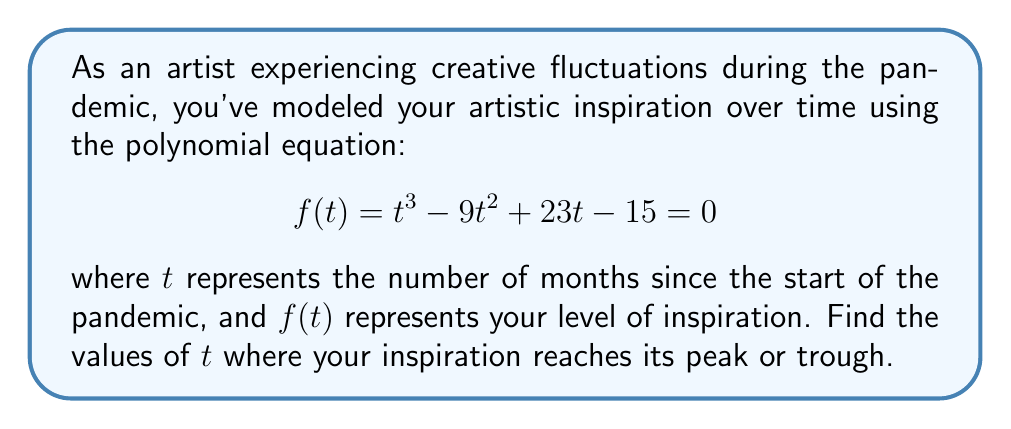Could you help me with this problem? To find the peak and trough points of inspiration, we need to find the roots of the derivative of $f(t)$. Here's how we proceed:

1) First, let's find the derivative of $f(t)$:
   $$f'(t) = 3t^2 - 18t + 23$$

2) To find the critical points, we set $f'(t) = 0$:
   $$3t^2 - 18t + 23 = 0$$

3) This is a quadratic equation. We can solve it using the quadratic formula:
   $$t = \frac{-b \pm \sqrt{b^2 - 4ac}}{2a}$$
   where $a=3$, $b=-18$, and $c=23$

4) Substituting these values:
   $$t = \frac{18 \pm \sqrt{(-18)^2 - 4(3)(23)}}{2(3)}$$
   $$t = \frac{18 \pm \sqrt{324 - 276}}{6}$$
   $$t = \frac{18 \pm \sqrt{48}}{6}$$
   $$t = \frac{18 \pm 4\sqrt{3}}{6}$$

5) Simplifying:
   $$t = 3 \pm \frac{2\sqrt{3}}{3}$$

6) Therefore, the two critical points are:
   $$t_1 = 3 + \frac{2\sqrt{3}}{3} \approx 4.15$$
   $$t_2 = 3 - \frac{2\sqrt{3}}{3} \approx 1.85$$

These points represent the months where your inspiration reaches its peak or trough.
Answer: $t = 3 \pm \frac{2\sqrt{3}}{3}$ 